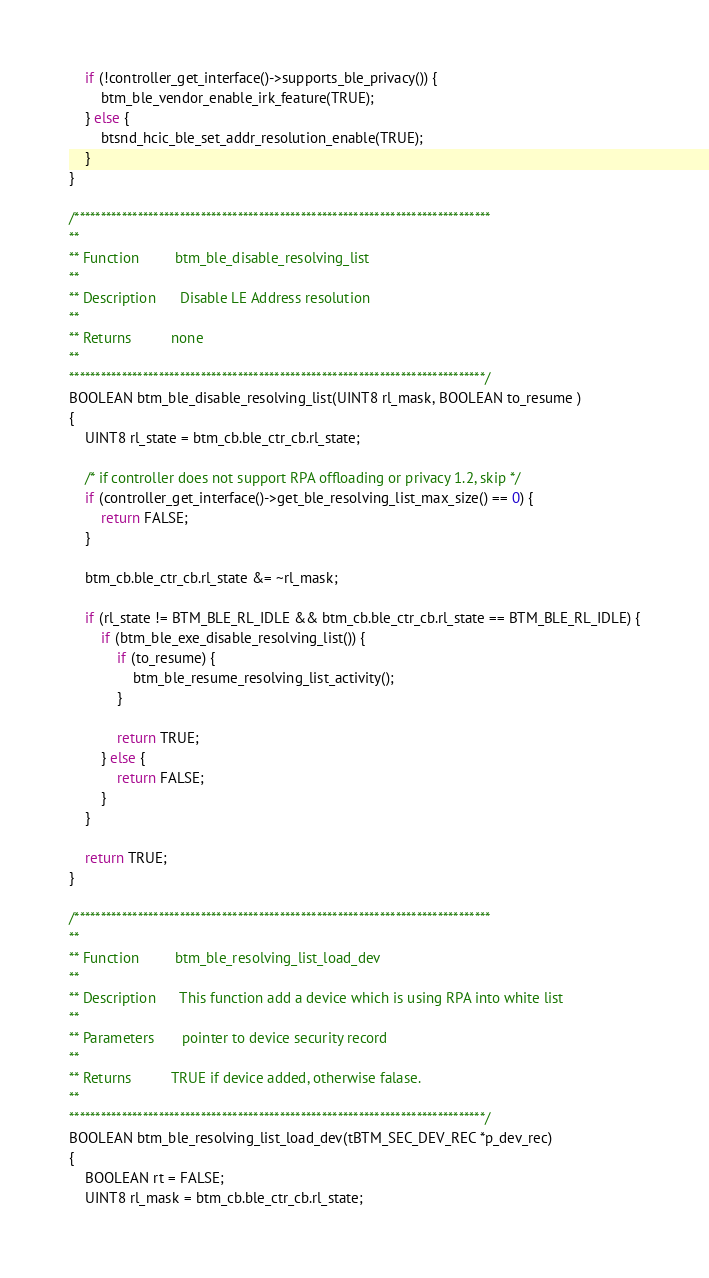<code> <loc_0><loc_0><loc_500><loc_500><_C_>
    if (!controller_get_interface()->supports_ble_privacy()) {
        btm_ble_vendor_enable_irk_feature(TRUE);
    } else {
        btsnd_hcic_ble_set_addr_resolution_enable(TRUE);
    }
}

/*******************************************************************************
**
** Function         btm_ble_disable_resolving_list
**
** Description      Disable LE Address resolution
**
** Returns          none
**
*******************************************************************************/
BOOLEAN btm_ble_disable_resolving_list(UINT8 rl_mask, BOOLEAN to_resume )
{
    UINT8 rl_state = btm_cb.ble_ctr_cb.rl_state;

    /* if controller does not support RPA offloading or privacy 1.2, skip */
    if (controller_get_interface()->get_ble_resolving_list_max_size() == 0) {
        return FALSE;
    }

    btm_cb.ble_ctr_cb.rl_state &= ~rl_mask;

    if (rl_state != BTM_BLE_RL_IDLE && btm_cb.ble_ctr_cb.rl_state == BTM_BLE_RL_IDLE) {
        if (btm_ble_exe_disable_resolving_list()) {
            if (to_resume) {
                btm_ble_resume_resolving_list_activity();
            }

            return TRUE;
        } else {
            return FALSE;
        }
    }

    return TRUE;
}

/*******************************************************************************
**
** Function         btm_ble_resolving_list_load_dev
**
** Description      This function add a device which is using RPA into white list
**
** Parameters       pointer to device security record
**
** Returns          TRUE if device added, otherwise falase.
**
*******************************************************************************/
BOOLEAN btm_ble_resolving_list_load_dev(tBTM_SEC_DEV_REC *p_dev_rec)
{
    BOOLEAN rt = FALSE;
    UINT8 rl_mask = btm_cb.ble_ctr_cb.rl_state;
</code> 